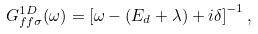<formula> <loc_0><loc_0><loc_500><loc_500>G _ { f f \sigma } ^ { 1 D } ( \omega ) = \left [ \omega - ( E _ { d } + \lambda ) + i \delta \right ] ^ { - 1 } ,</formula> 